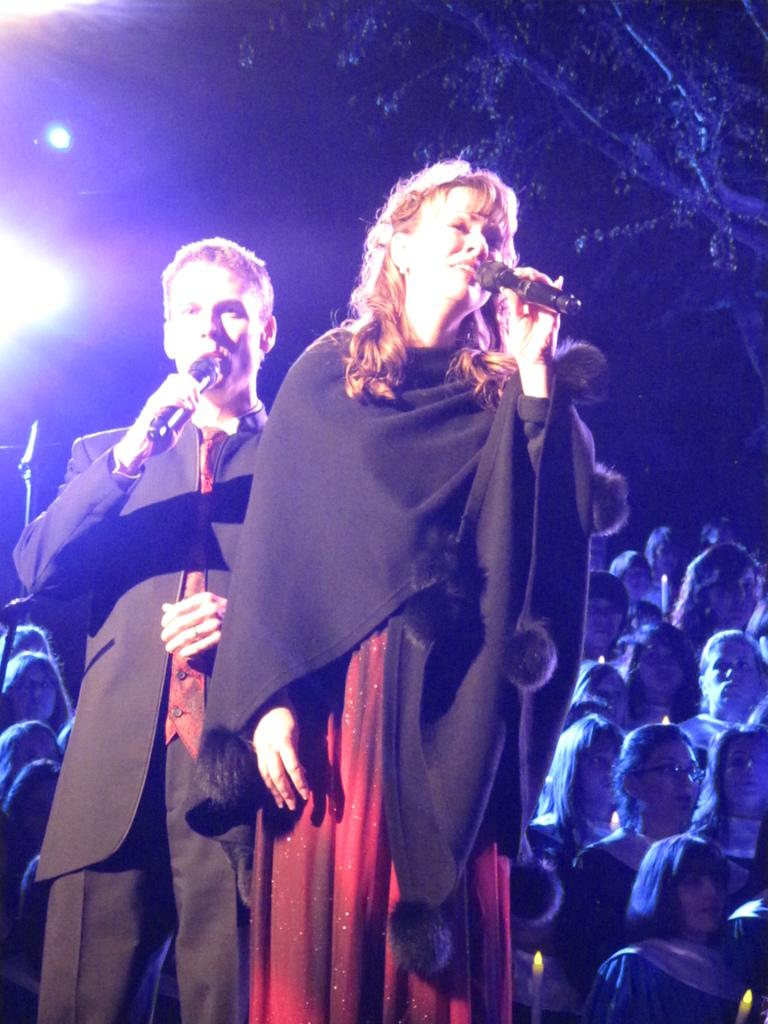Who are the two people in the image? There is a lady and a man in the image. What are the lady and the man holding in their hands? The lady and the man are holding mics in their hands. What are the lady and the man doing with the mics? The lady and the man are singing while holding the mics. Can you describe the background of the image? There are people standing in the background of the image. How many babies are sitting on the tree in the image? There are no babies or trees present in the image. 